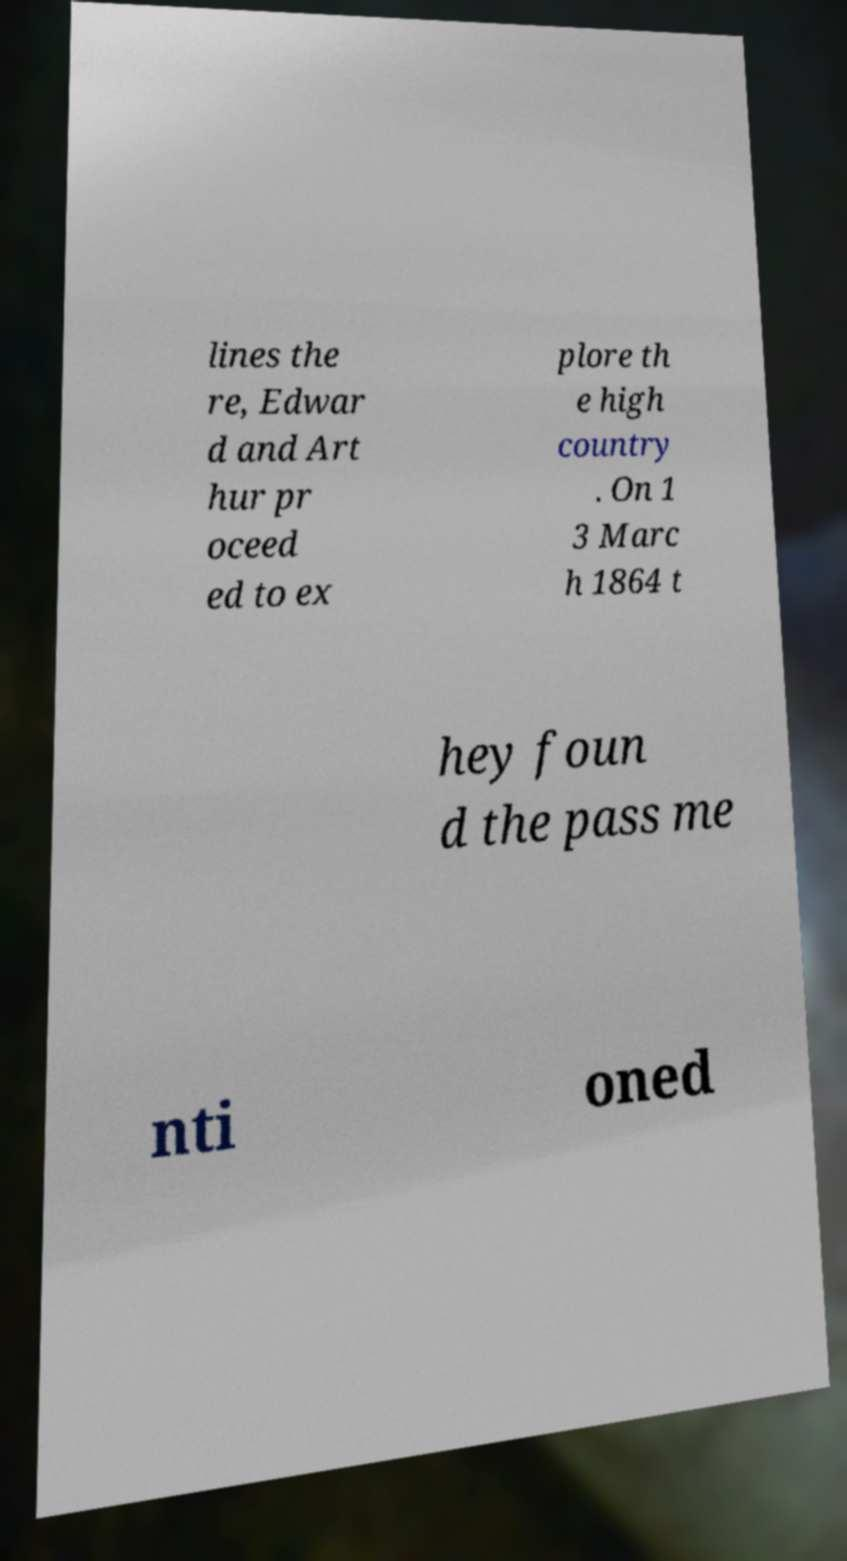Could you extract and type out the text from this image? lines the re, Edwar d and Art hur pr oceed ed to ex plore th e high country . On 1 3 Marc h 1864 t hey foun d the pass me nti oned 